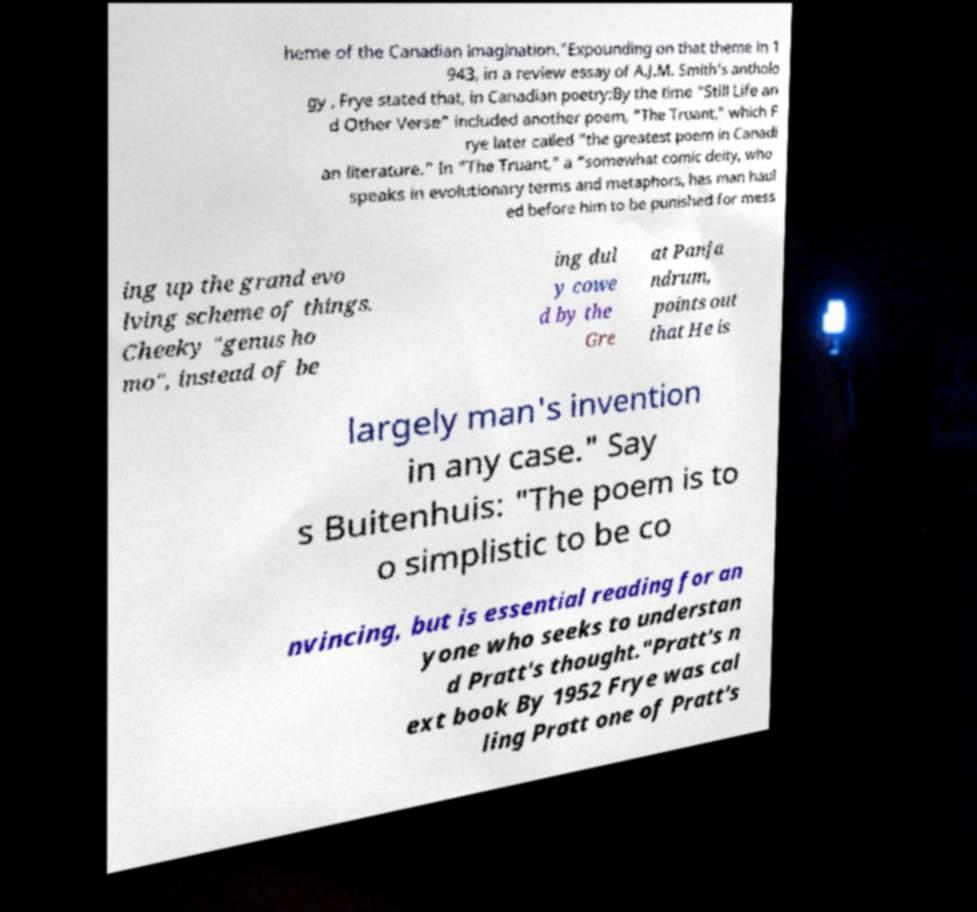What messages or text are displayed in this image? I need them in a readable, typed format. heme of the Canadian imagination."Expounding on that theme in 1 943, in a review essay of A.J.M. Smith's antholo gy , Frye stated that, in Canadian poetry:By the time "Still Life an d Other Verse" included another poem, "The Truant," which F rye later called "the greatest poem in Canadi an literature." In "The Truant," a "somewhat comic deity, who speaks in evolutionary terms and metaphors, has man haul ed before him to be punished for mess ing up the grand evo lving scheme of things. Cheeky "genus ho mo", instead of be ing dul y cowe d by the Gre at Panja ndrum, points out that He is largely man's invention in any case." Say s Buitenhuis: "The poem is to o simplistic to be co nvincing, but is essential reading for an yone who seeks to understan d Pratt's thought."Pratt's n ext book By 1952 Frye was cal ling Pratt one of Pratt's 